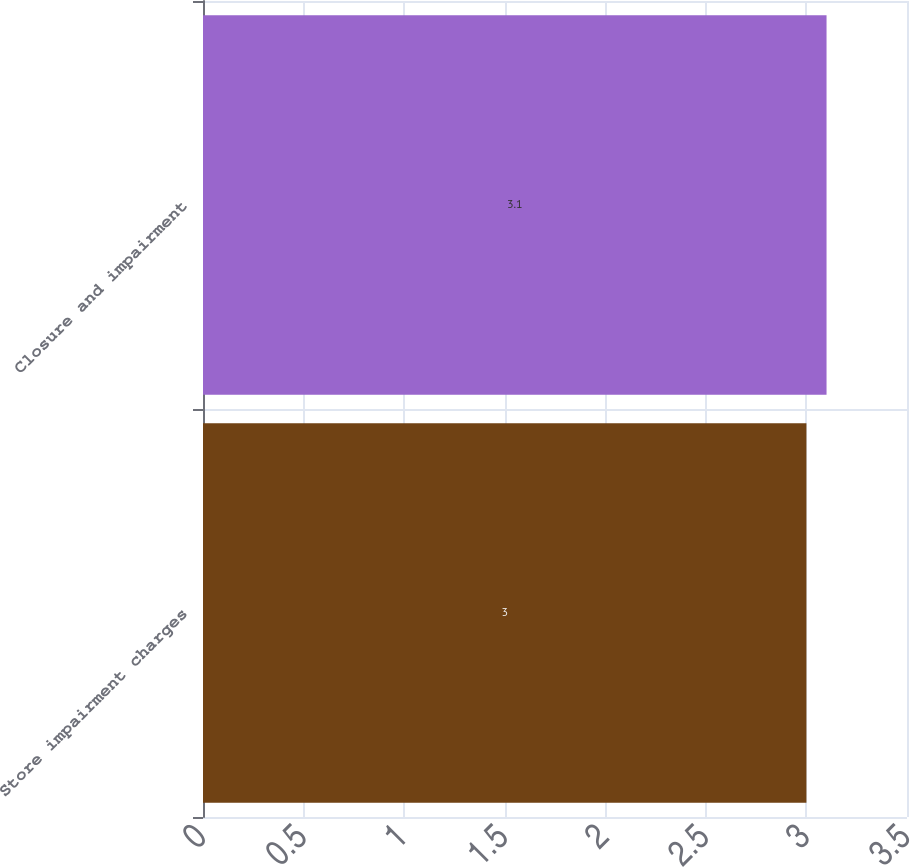Convert chart. <chart><loc_0><loc_0><loc_500><loc_500><bar_chart><fcel>Store impairment charges<fcel>Closure and impairment<nl><fcel>3<fcel>3.1<nl></chart> 